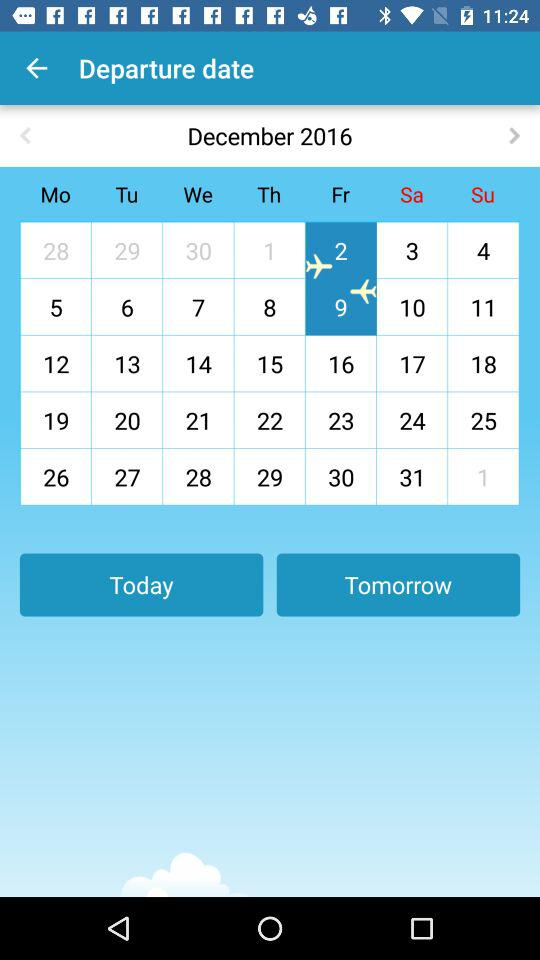What is the departure date? The departure date is 2. 